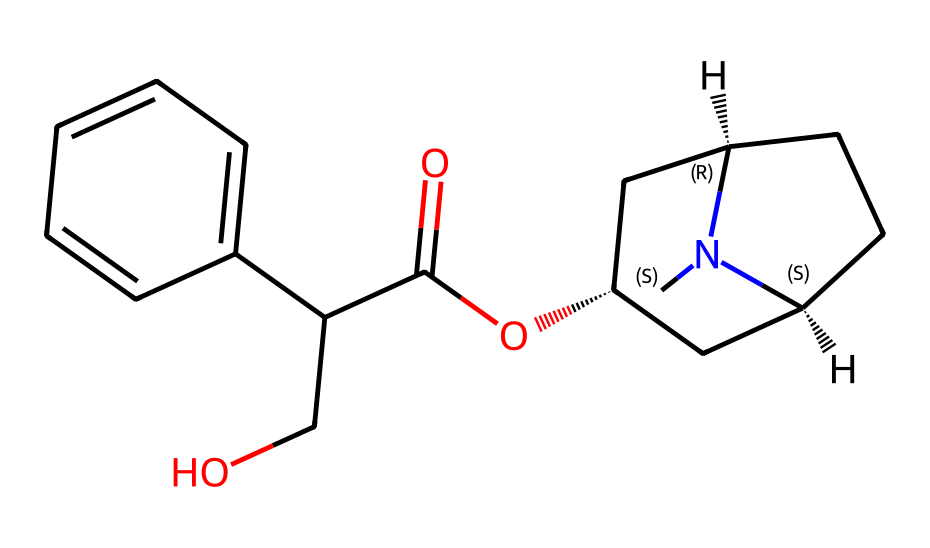What is the molecular formula of atropine? To determine the molecular formula, we analyze the SMILES structure. Counting the atoms, we find 17 carbon atoms (C), 23 hydrogen atoms (H), 1 nitrogen atom (N), and 3 oxygen atoms (O). Thus, the molecular formula combines these counts.
Answer: C17H23N1O3 How many rings are present in atropine's structure? By examining the structure, we see two distinct cyclic components that form rings. Specifically, there is one bicyclic system in the compound. Therefore, the total number of rings is two.
Answer: 2 Which functional group is present in atropine? Looking at the SMILES representation, we identify a carboxylic acid functional group indicated by the -COOH structure within the compound's arrangement. There is also an ester linkage. Thus, the carboxylic group is a defining characteristic of this structure.
Answer: carboxylic acid What is the stereochemistry around the chiral centers in atropine? The stereocenters in the SMILES can be identified at the carbon atoms marked by "@" symbols. The structure indicates one S configuration and one R configuration at these centers. We analyze the 3D orientation based on spatial arrangement rules to deduce this.
Answer: 1 S, 1 R How many hydrogen bond donors are present in atropine? Reviewing the structure, we note that the presence of the alcohol (-OH) part contributes one hydrogen bond donor. The nitrogen also has hydrogen that could participate in hydrogen bonding. Therefore, the total count of hydrogen bond donors amounts to two.
Answer: 2 